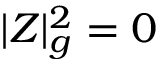Convert formula to latex. <formula><loc_0><loc_0><loc_500><loc_500>| Z | _ { g } ^ { 2 } = 0</formula> 